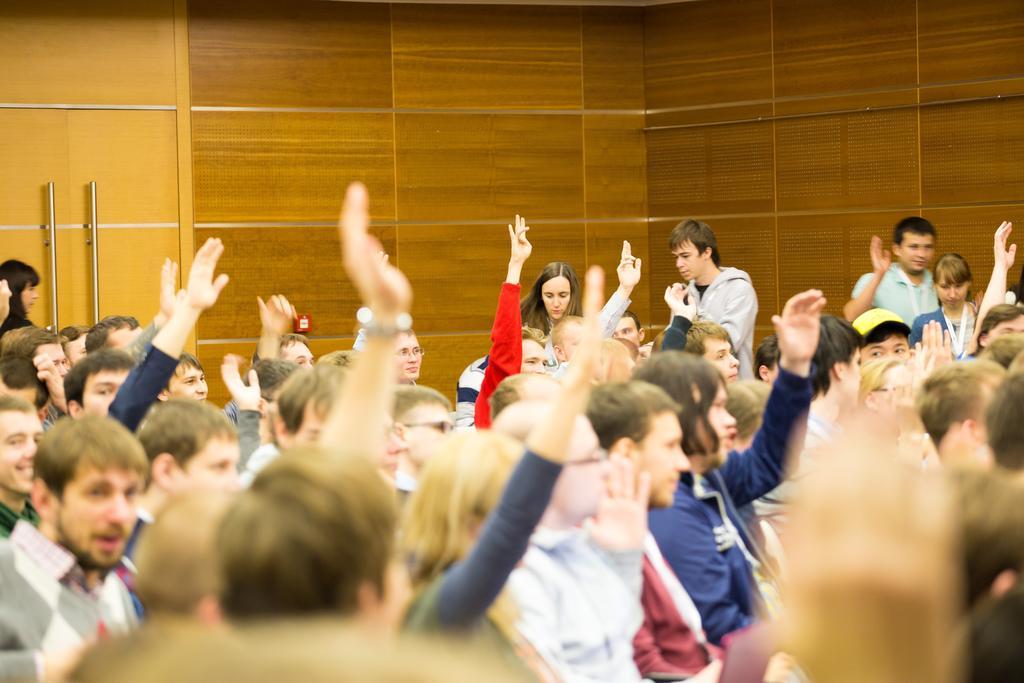How would you summarize this image in a sentence or two? In this image we can see a few people, some of them are raising their hands, there is a wall, doors, and handles. 